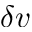Convert formula to latex. <formula><loc_0><loc_0><loc_500><loc_500>\delta v</formula> 